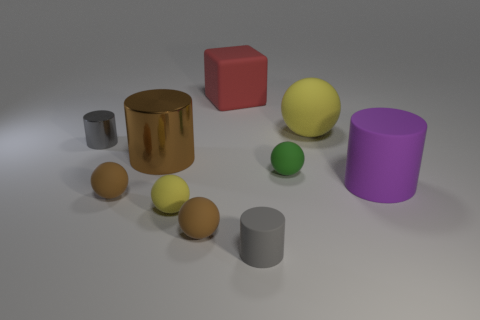Subtract all purple cylinders. How many cylinders are left? 3 Subtract all brown balls. How many balls are left? 3 Subtract all cyan balls. Subtract all blue blocks. How many balls are left? 5 Subtract all cubes. How many objects are left? 9 Add 9 large yellow balls. How many large yellow balls exist? 10 Subtract 0 blue spheres. How many objects are left? 10 Subtract all purple objects. Subtract all yellow spheres. How many objects are left? 7 Add 1 gray rubber cylinders. How many gray rubber cylinders are left? 2 